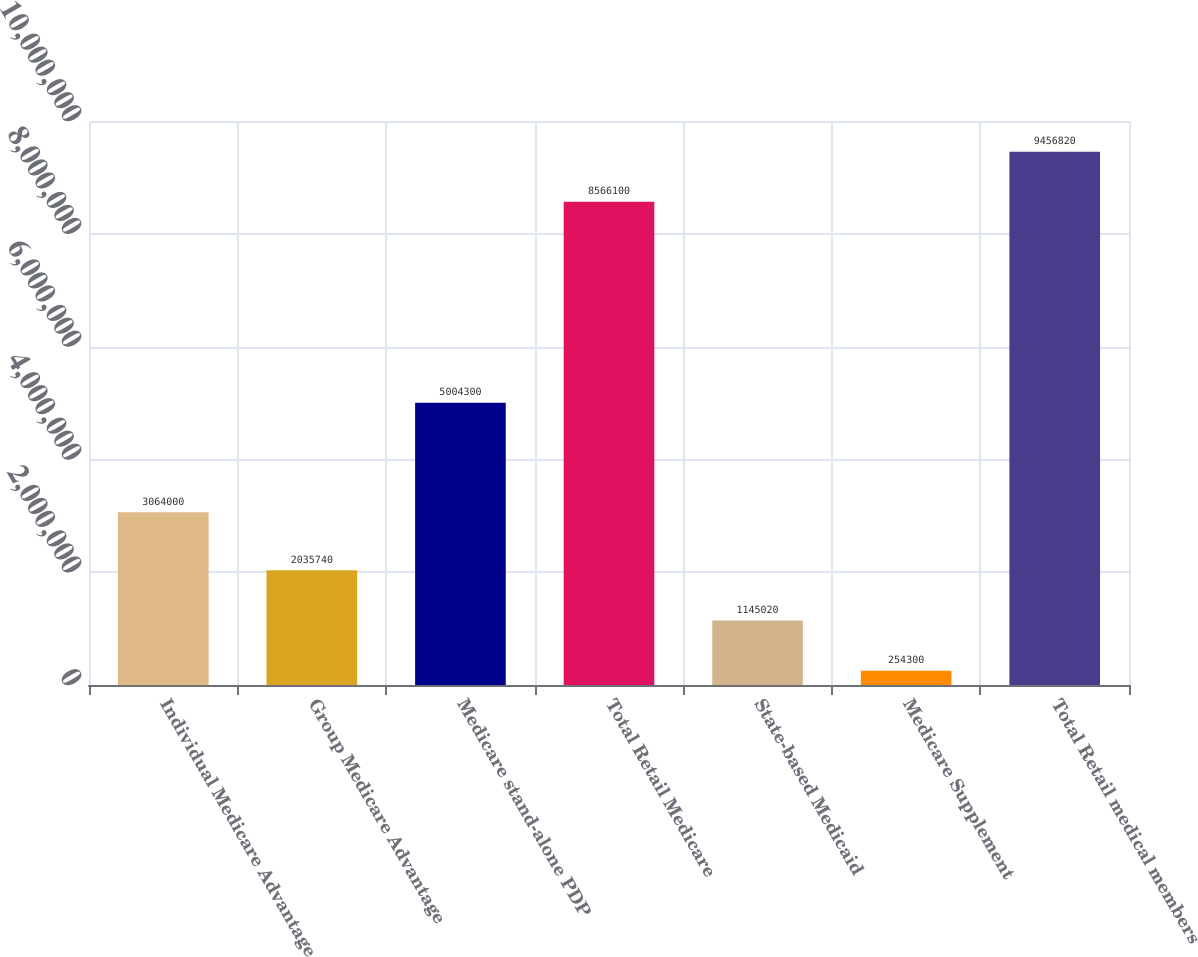<chart> <loc_0><loc_0><loc_500><loc_500><bar_chart><fcel>Individual Medicare Advantage<fcel>Group Medicare Advantage<fcel>Medicare stand-alone PDP<fcel>Total Retail Medicare<fcel>State-based Medicaid<fcel>Medicare Supplement<fcel>Total Retail medical members<nl><fcel>3.064e+06<fcel>2.03574e+06<fcel>5.0043e+06<fcel>8.5661e+06<fcel>1.14502e+06<fcel>254300<fcel>9.45682e+06<nl></chart> 